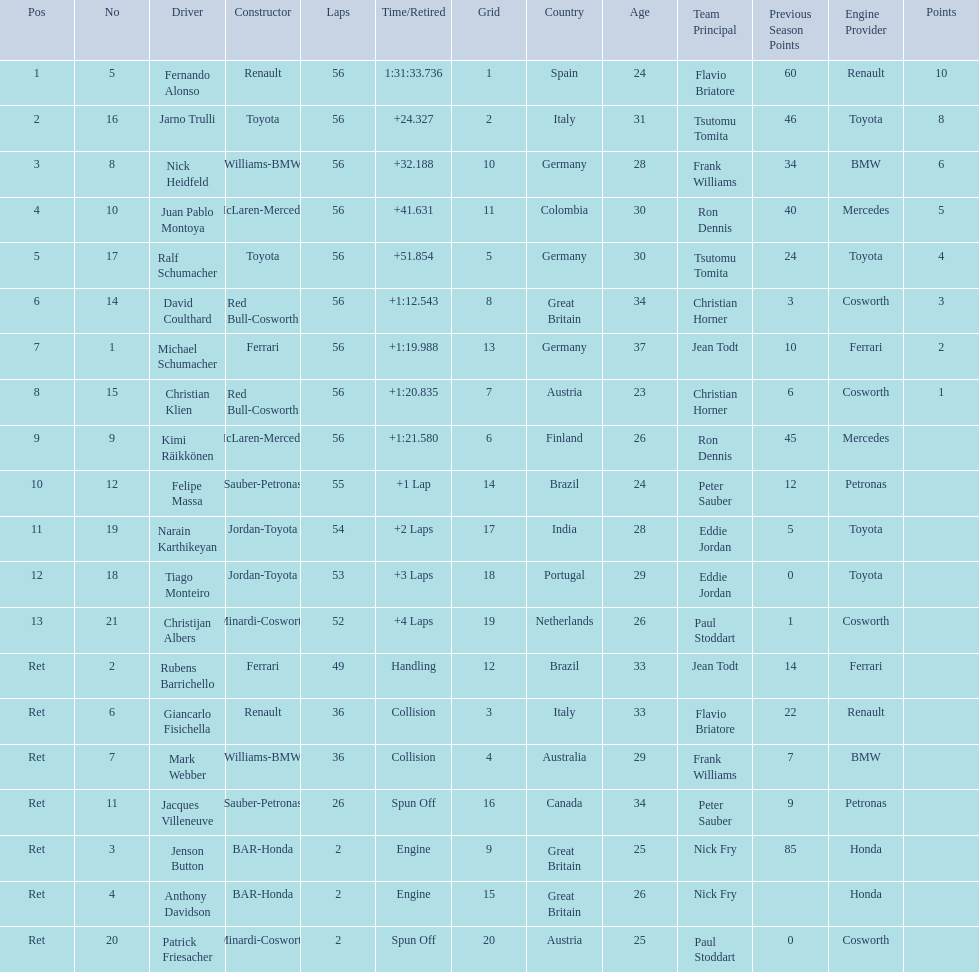Who finished before nick heidfeld? Jarno Trulli. 